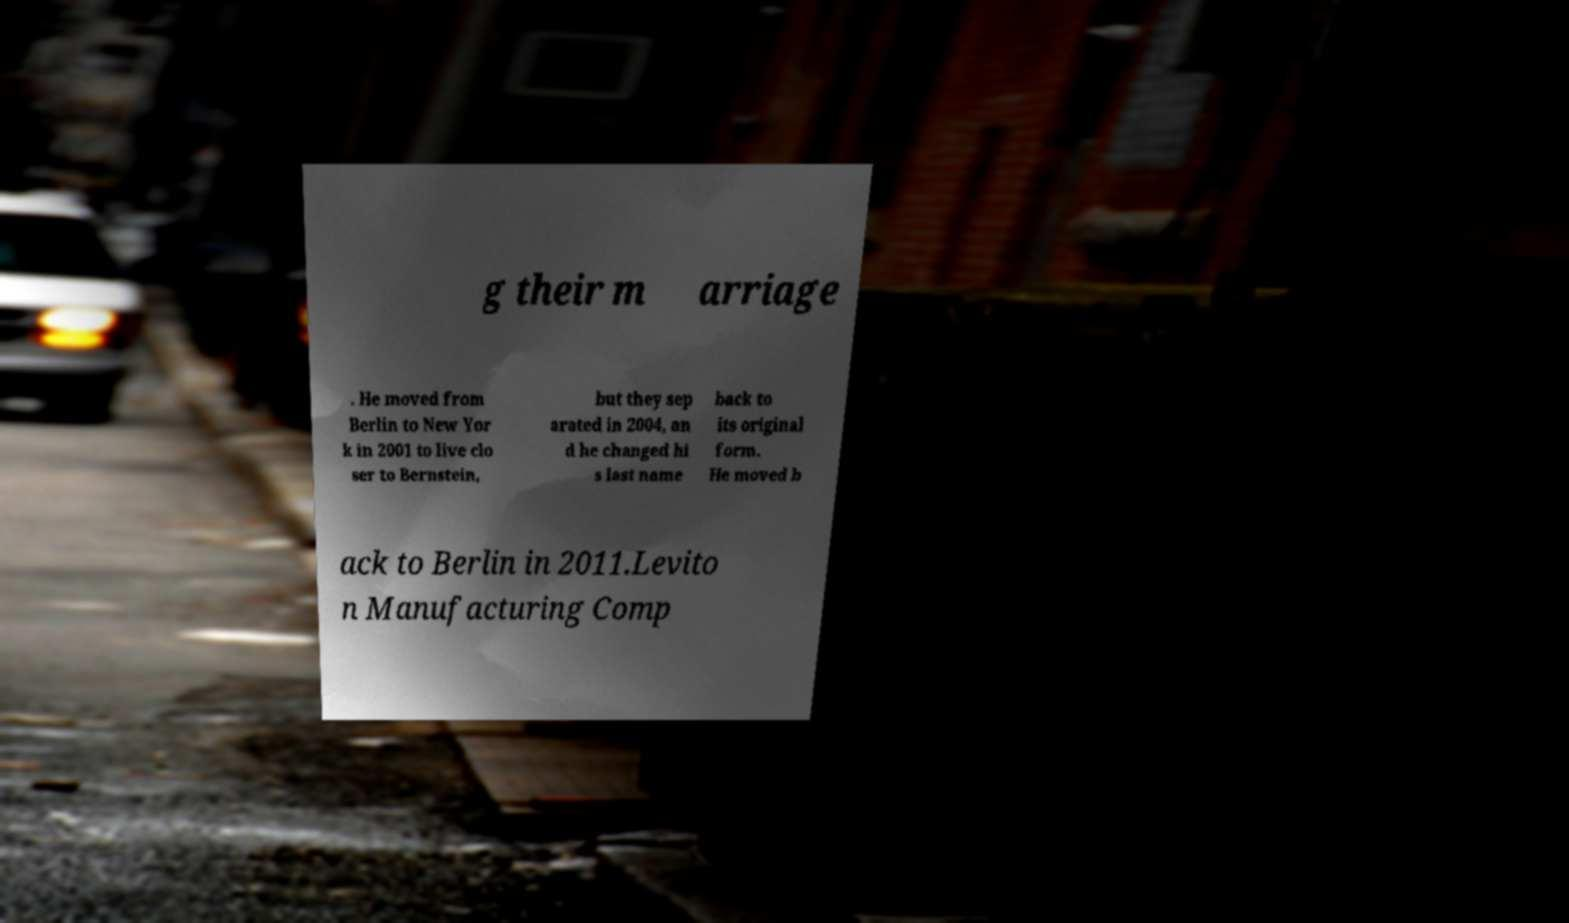Can you accurately transcribe the text from the provided image for me? g their m arriage . He moved from Berlin to New Yor k in 2001 to live clo ser to Bernstein, but they sep arated in 2004, an d he changed hi s last name back to its original form. He moved b ack to Berlin in 2011.Levito n Manufacturing Comp 